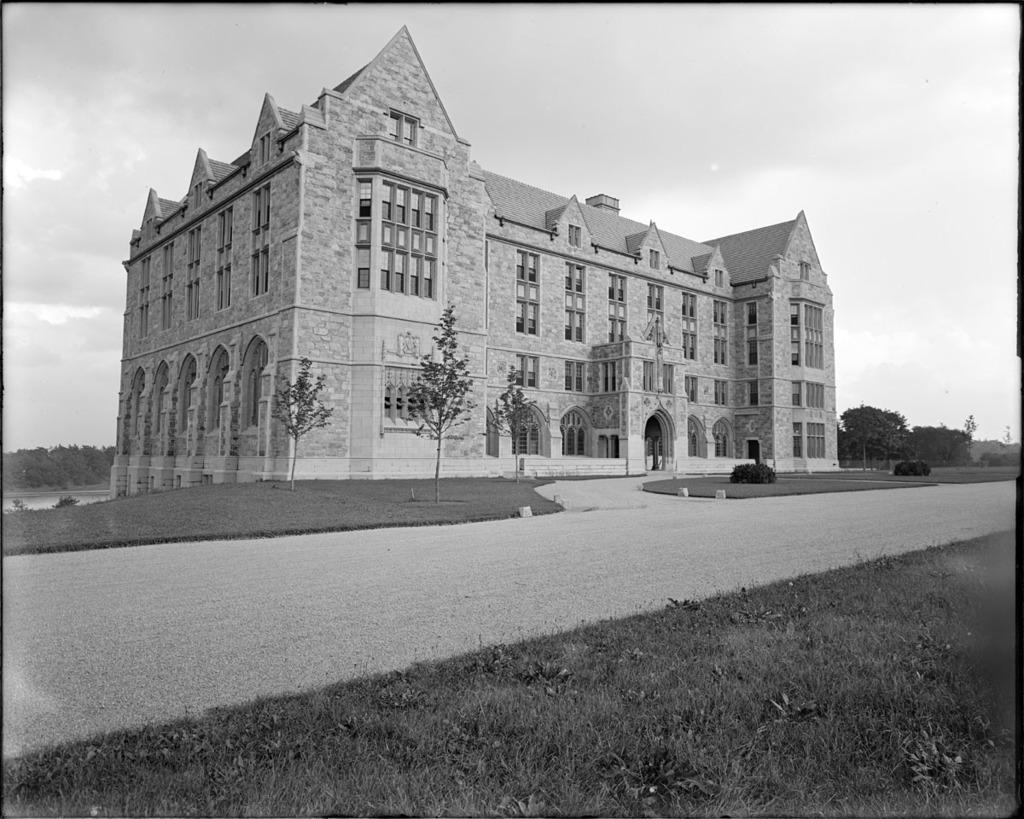What type of structure is present in the image? There is a building in the image. What natural elements can be seen in the image? There are trees, plants, and water visible in the image. What type of ground cover is present in the image? There is grass on the ground in the image. How would you describe the sky in the image? The sky is cloudy in the image. What type of attraction is present in the image? There is no attraction mentioned or visible in the image. Is there a hall where people can gather in the image? There is no hall or indication of a gathering space visible in the image. 